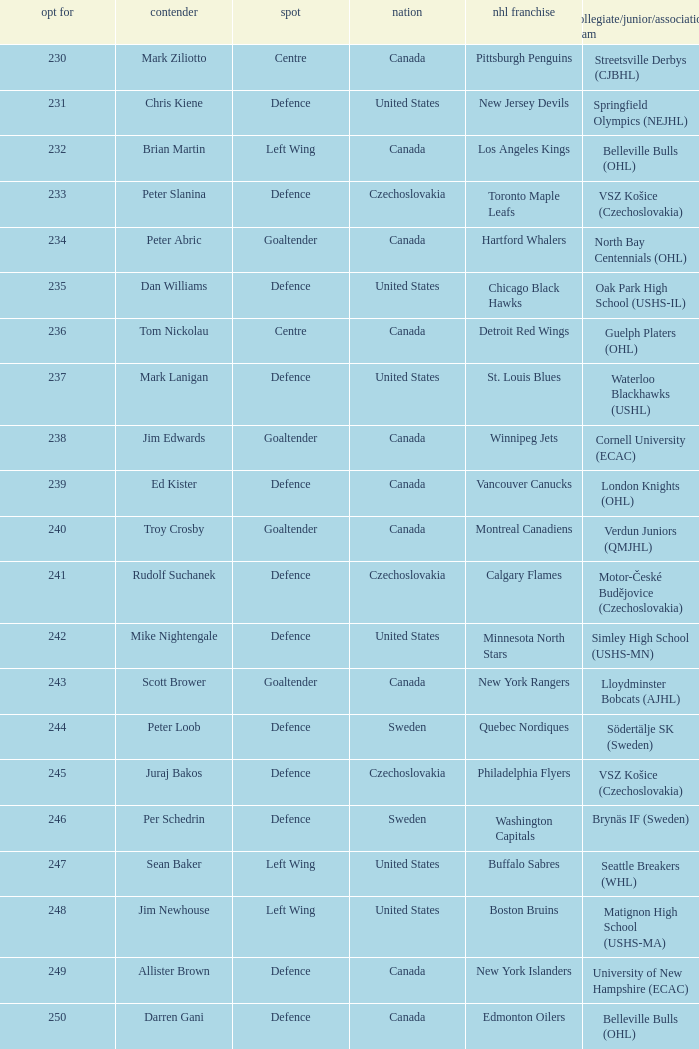To which organziation does the  winnipeg jets belong to? Cornell University (ECAC). 